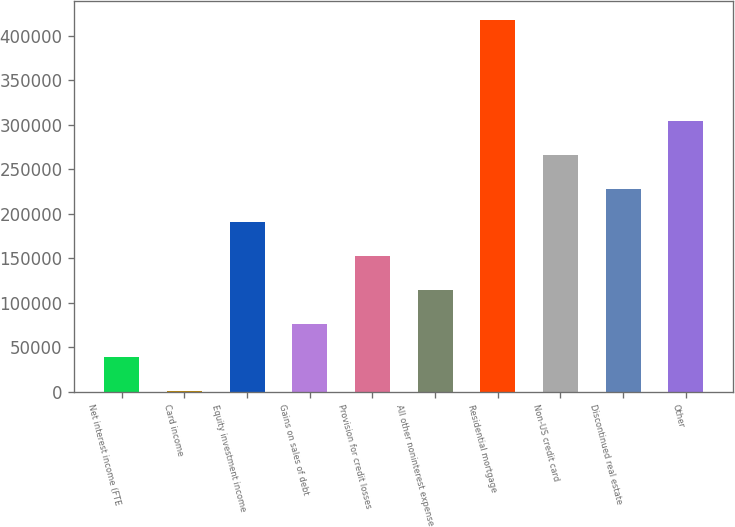Convert chart to OTSL. <chart><loc_0><loc_0><loc_500><loc_500><bar_chart><fcel>Net interest income (FTE<fcel>Card income<fcel>Equity investment income<fcel>Gains on sales of debt<fcel>Provision for credit losses<fcel>All other noninterest expense<fcel>Residential mortgage<fcel>Non-US credit card<fcel>Discontinued real estate<fcel>Other<nl><fcel>38443.8<fcel>465<fcel>190359<fcel>76422.6<fcel>152380<fcel>114401<fcel>418232<fcel>266317<fcel>228338<fcel>304295<nl></chart> 